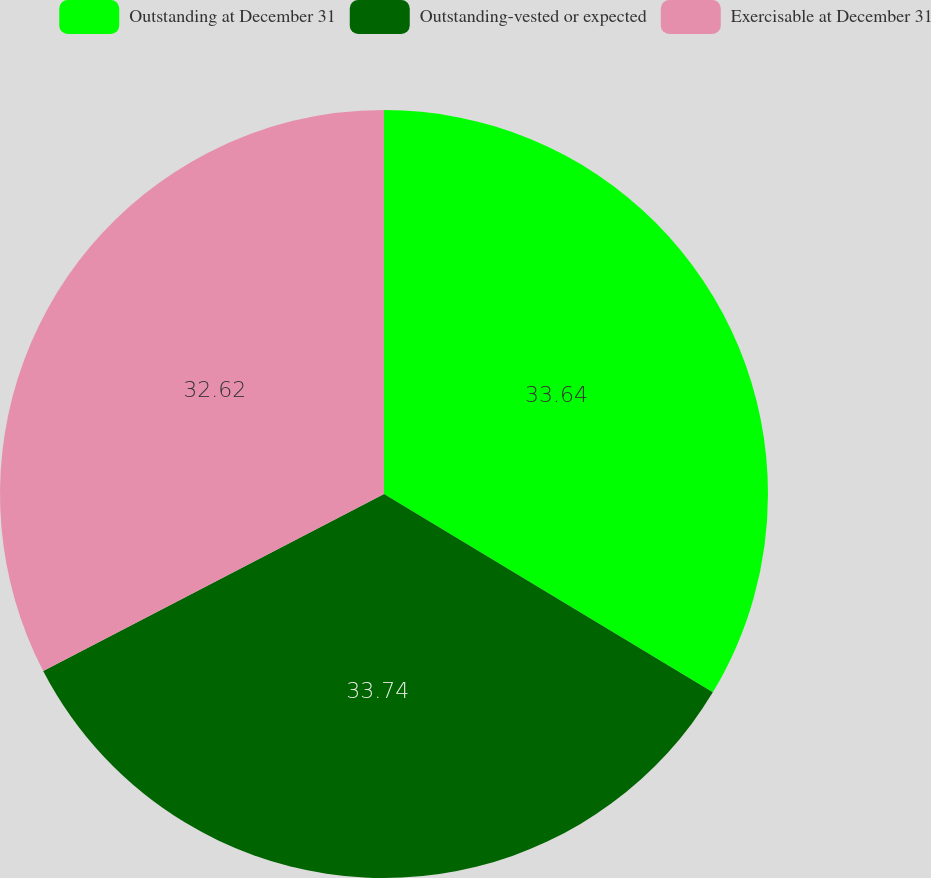Convert chart to OTSL. <chart><loc_0><loc_0><loc_500><loc_500><pie_chart><fcel>Outstanding at December 31<fcel>Outstanding-vested or expected<fcel>Exercisable at December 31<nl><fcel>33.64%<fcel>33.74%<fcel>32.62%<nl></chart> 